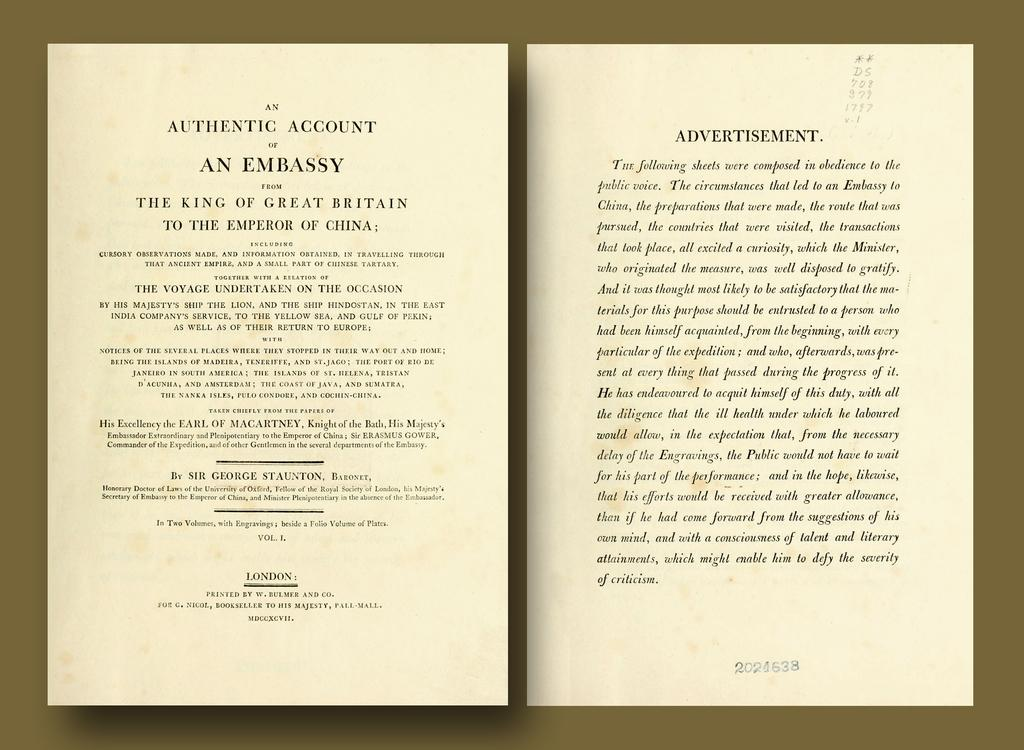<image>
Present a compact description of the photo's key features. A book open to the page titled Authentic Account of An Embassy. 